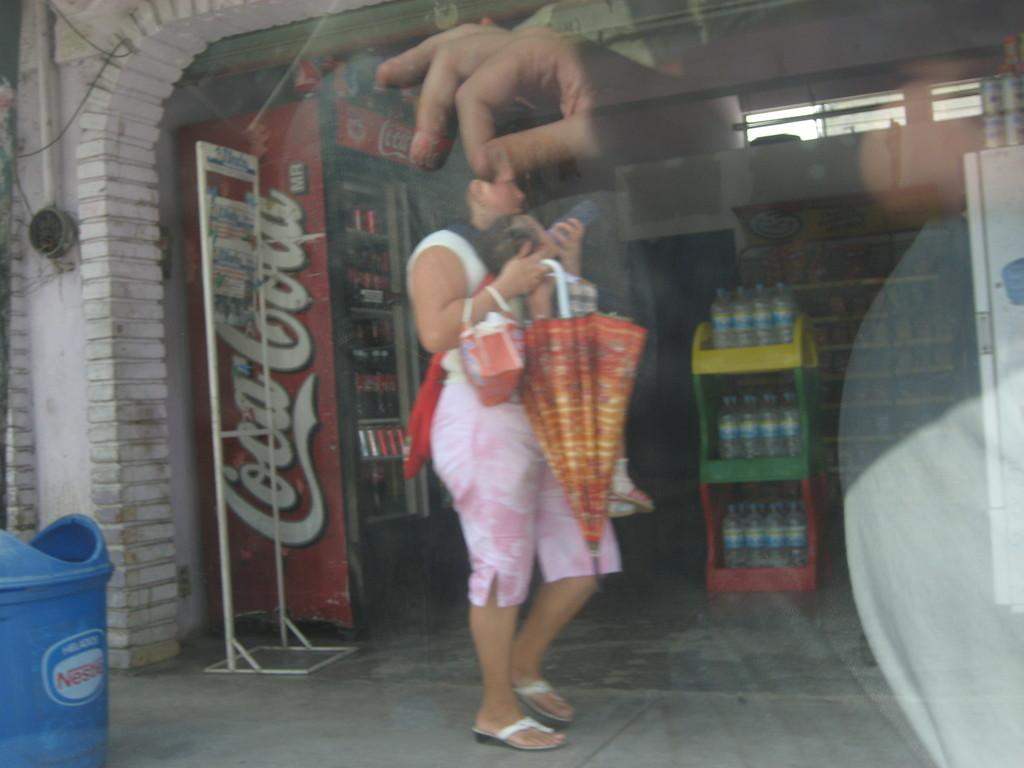Provide a one-sentence caption for the provided image. A woman holding an upside down umbrella and handbag stands perpendicular to the camera outside a store front near a Coca Cola machine. 